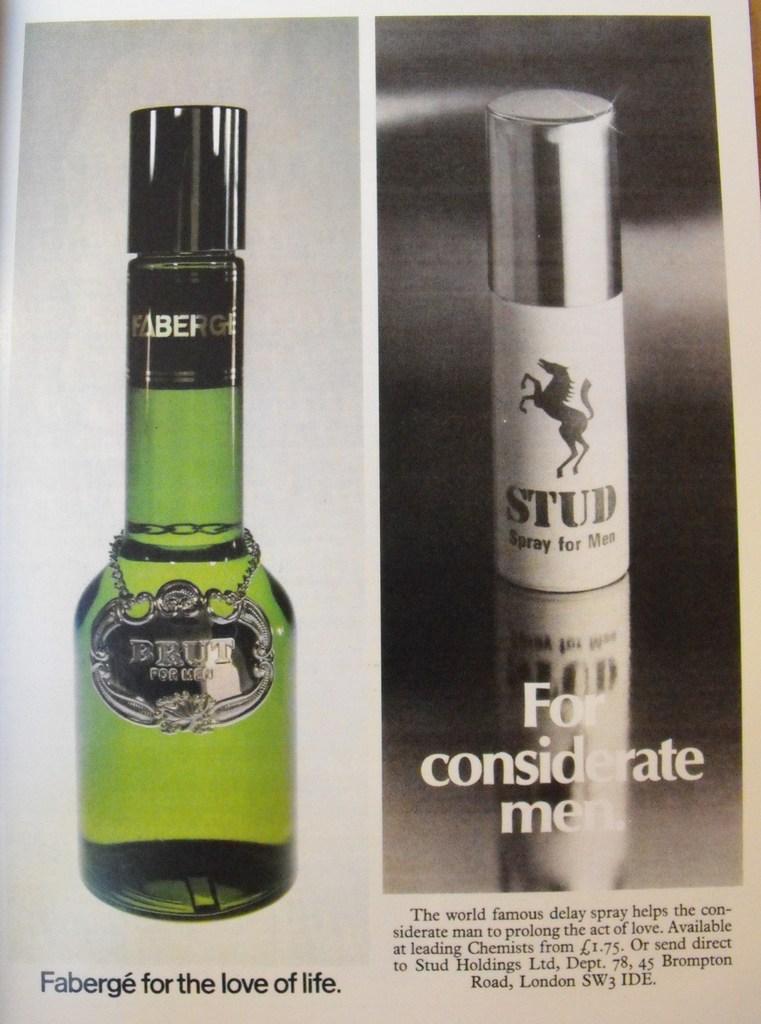What brand is the white bottle?
Ensure brevity in your answer.  Stud. Is the stud for men?
Keep it short and to the point. Yes. 